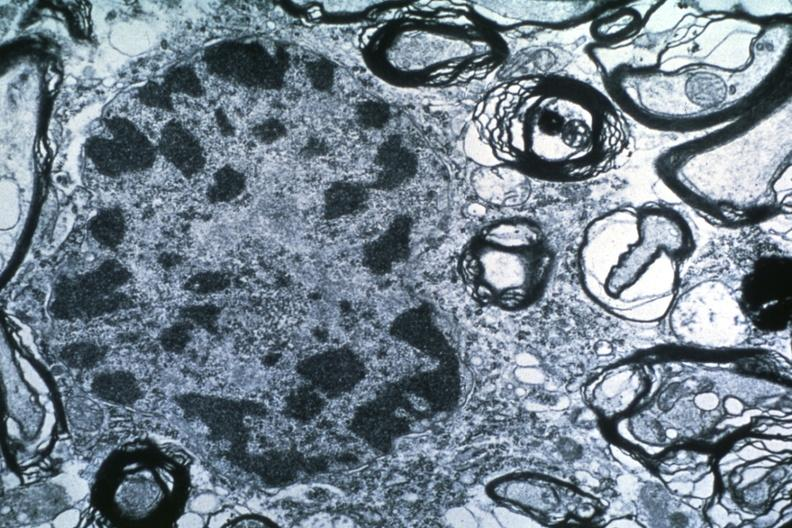does sugar coated show dr garcia tumors 51?
Answer the question using a single word or phrase. No 